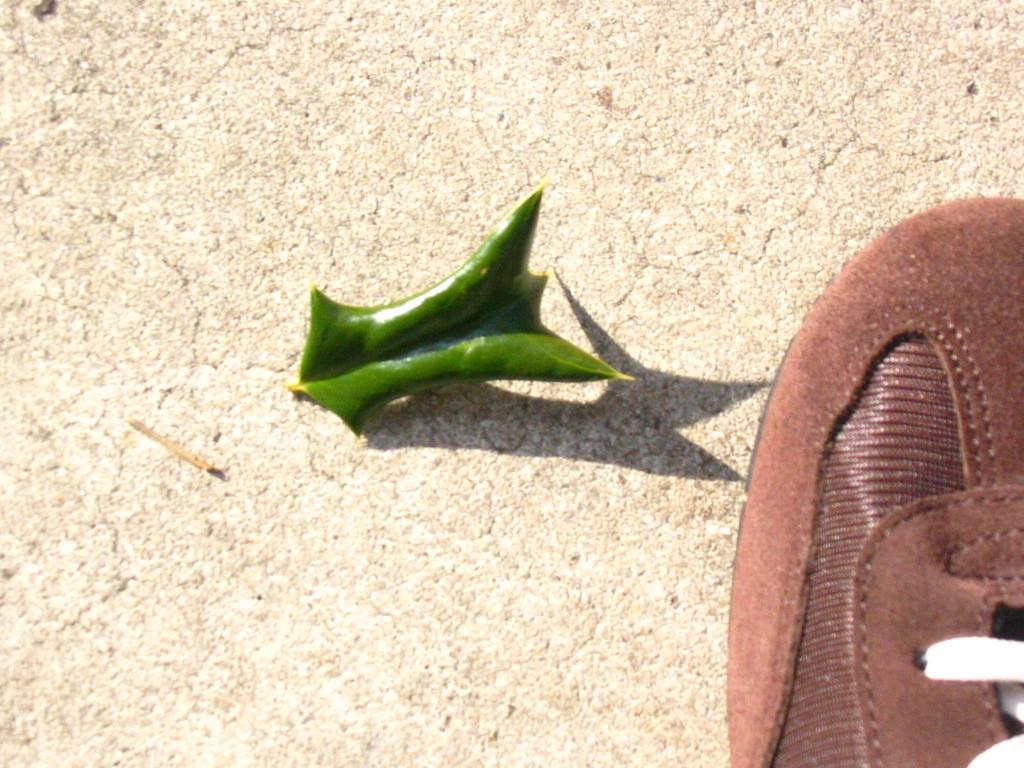What object can be seen in the image that is typically worn on the foot? There is a shoe in the image that is typically worn on the foot. What natural object is also present in the image? There is a leaf in the image. Where are the shoe and leaf located in the image? The shoe and leaf are on a path. What type of government is depicted in the image? There is no depiction of a government in the image; it features a shoe and a leaf on a path. What is the weather like in the image? The provided facts do not mention the weather, so it cannot be determined from the image. 